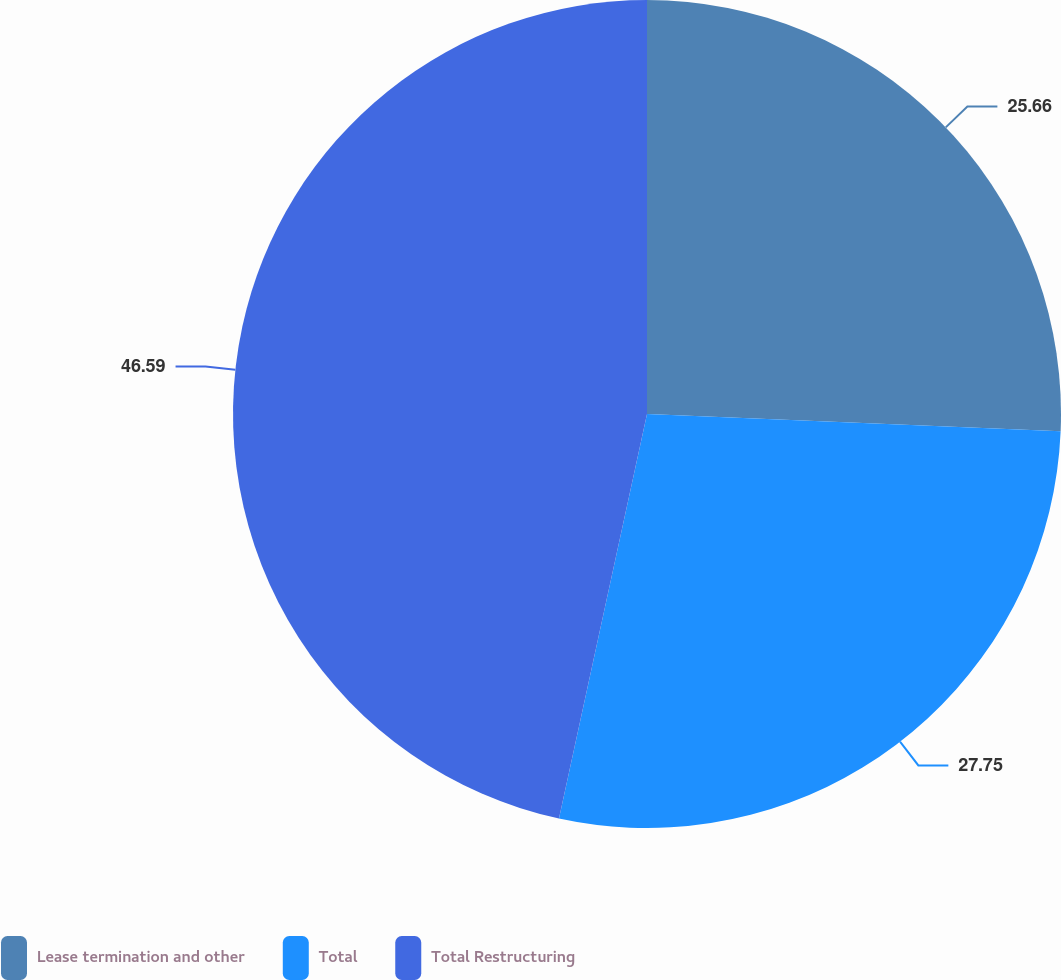Convert chart. <chart><loc_0><loc_0><loc_500><loc_500><pie_chart><fcel>Lease termination and other<fcel>Total<fcel>Total Restructuring<nl><fcel>25.66%<fcel>27.75%<fcel>46.59%<nl></chart> 